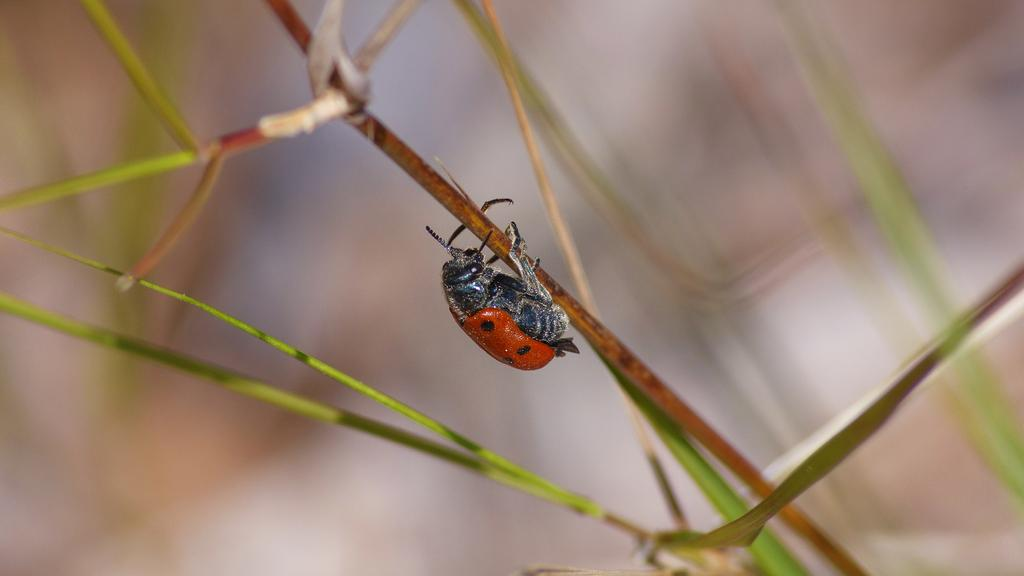What type of creature can be seen in the image? There is an insect in the image. Where is the insect located? The insect is on the grass. What brand of toothpaste is the insect using in the image? There is no toothpaste present in the image, and insects do not use toothpaste. How many cars can be seen in the image? There are no cars present in the image. 